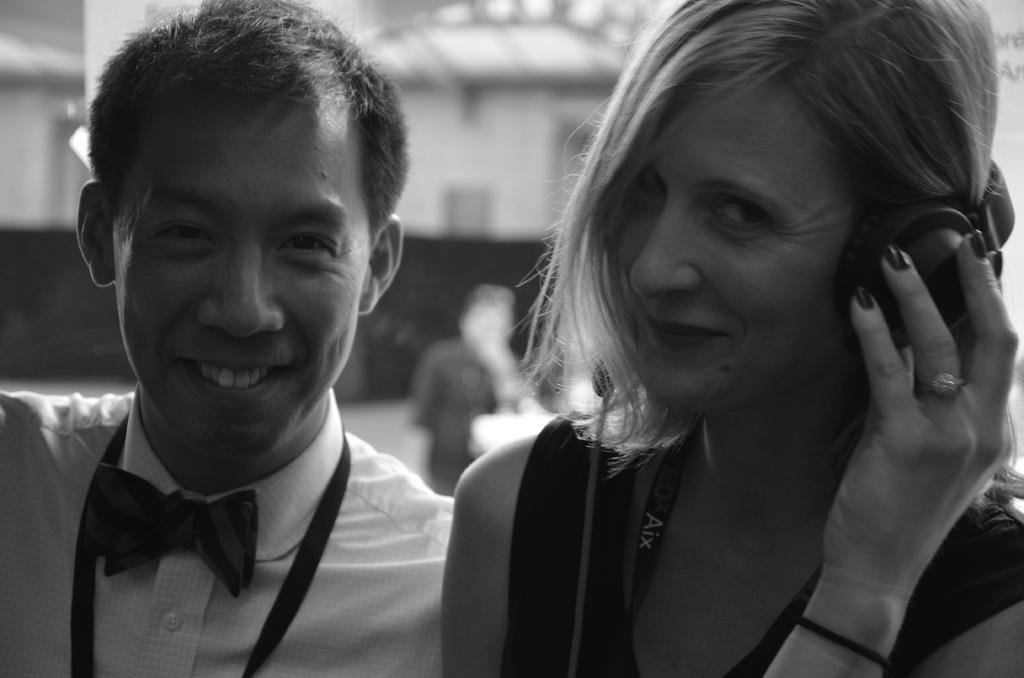How many people are present in the image? There is one person visible in the image, which is a man. What is the woman in the image wearing? The woman is wearing a headset. What is the facial expression of the man and the woman in the image? Both the man and the woman are smiling in the image. What can be seen in the background of the image? The background of the image is blurred. What type of structure is present in the image? There is a wall in the image. What type of arm is visible in the image? There is no arm visible in the image. Can you see a skateboard being used by the man in the image? There is no skateboard present in the image. 